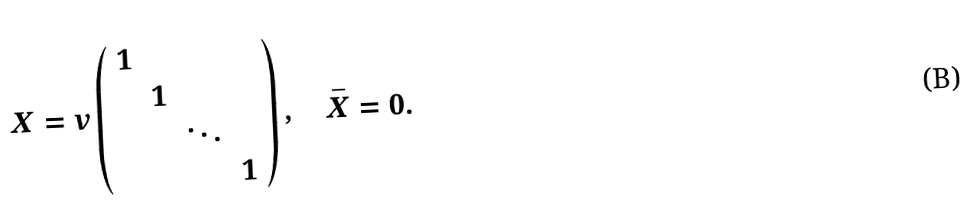Convert formula to latex. <formula><loc_0><loc_0><loc_500><loc_500>X = v \left ( \begin{array} { c c c c } 1 & & & \\ & 1 & & \\ & & \ddots & \\ & & & 1 \end{array} \right ) , \quad \bar { X } = 0 .</formula> 